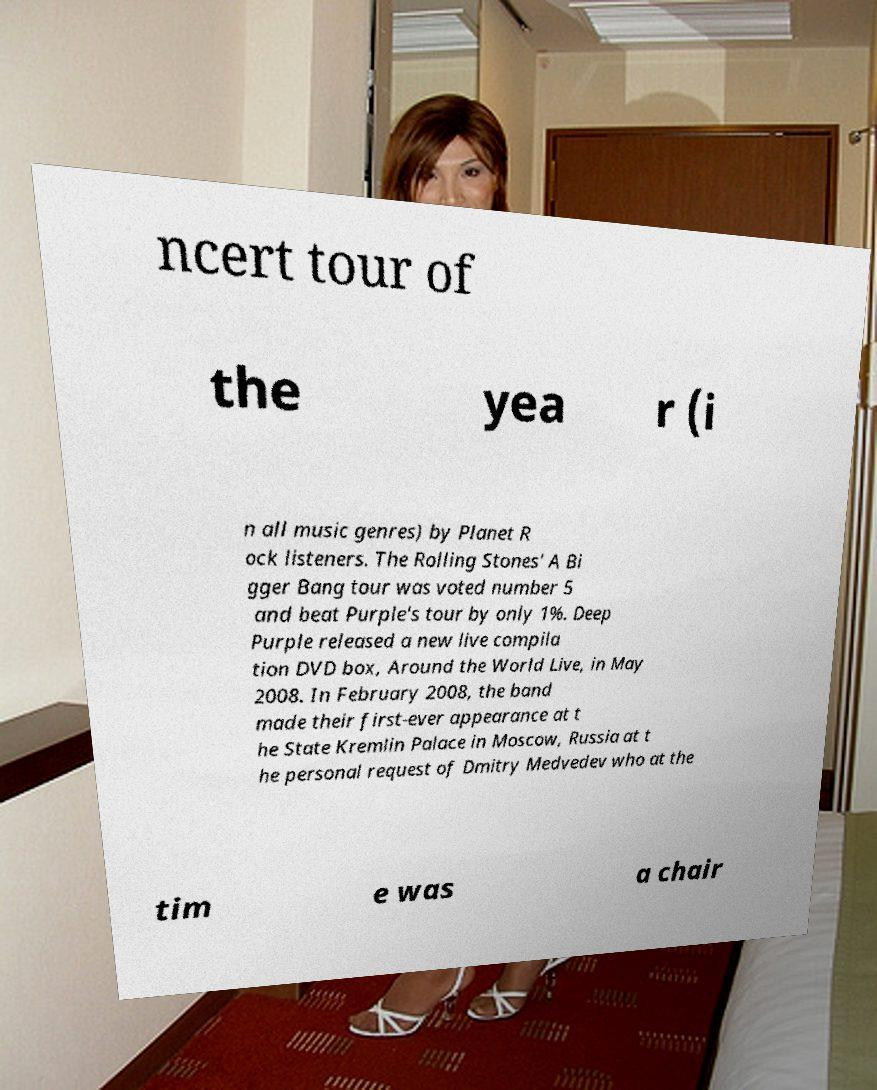For documentation purposes, I need the text within this image transcribed. Could you provide that? ncert tour of the yea r (i n all music genres) by Planet R ock listeners. The Rolling Stones' A Bi gger Bang tour was voted number 5 and beat Purple's tour by only 1%. Deep Purple released a new live compila tion DVD box, Around the World Live, in May 2008. In February 2008, the band made their first-ever appearance at t he State Kremlin Palace in Moscow, Russia at t he personal request of Dmitry Medvedev who at the tim e was a chair 